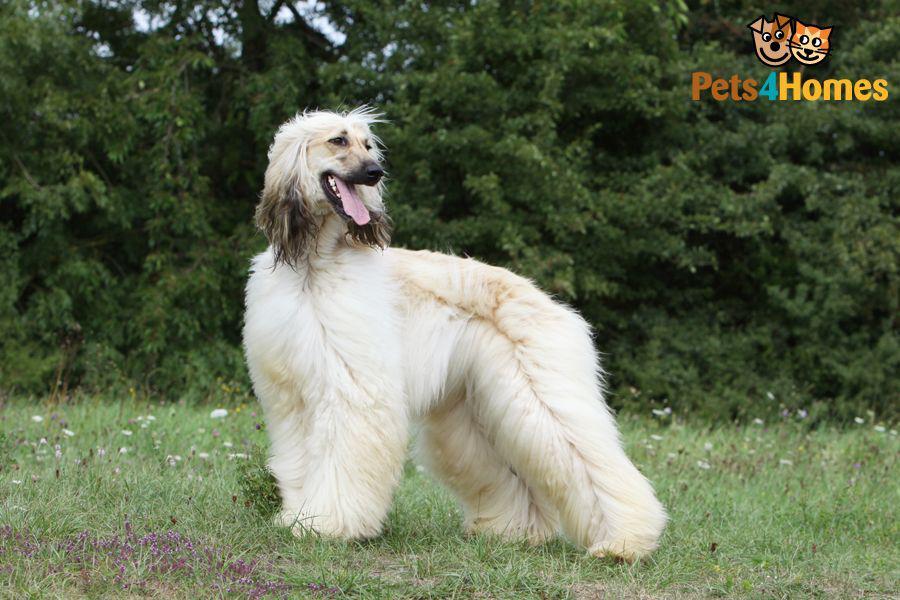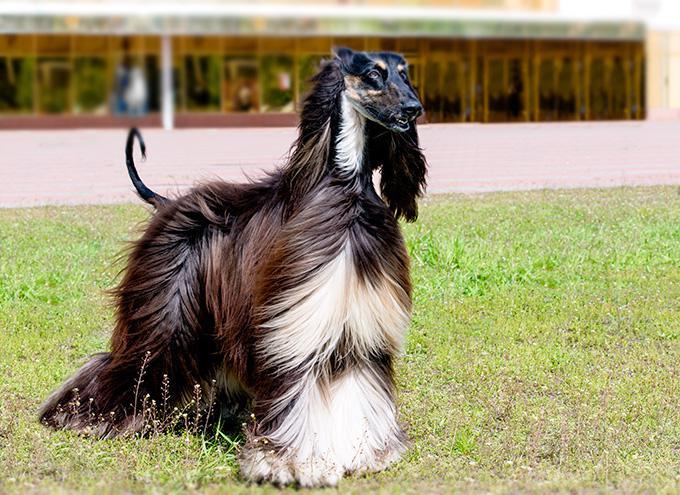The first image is the image on the left, the second image is the image on the right. Evaluate the accuracy of this statement regarding the images: "Both images show hounds standing with all four paws on the grass.". Is it true? Answer yes or no. Yes. The first image is the image on the left, the second image is the image on the right. Analyze the images presented: Is the assertion "The dog in the right photo is standing in the grass and facing toward the right." valid? Answer yes or no. Yes. The first image is the image on the left, the second image is the image on the right. For the images shown, is this caption "An image shows a creamy peach colored hound standing with tail curling upward." true? Answer yes or no. No. 